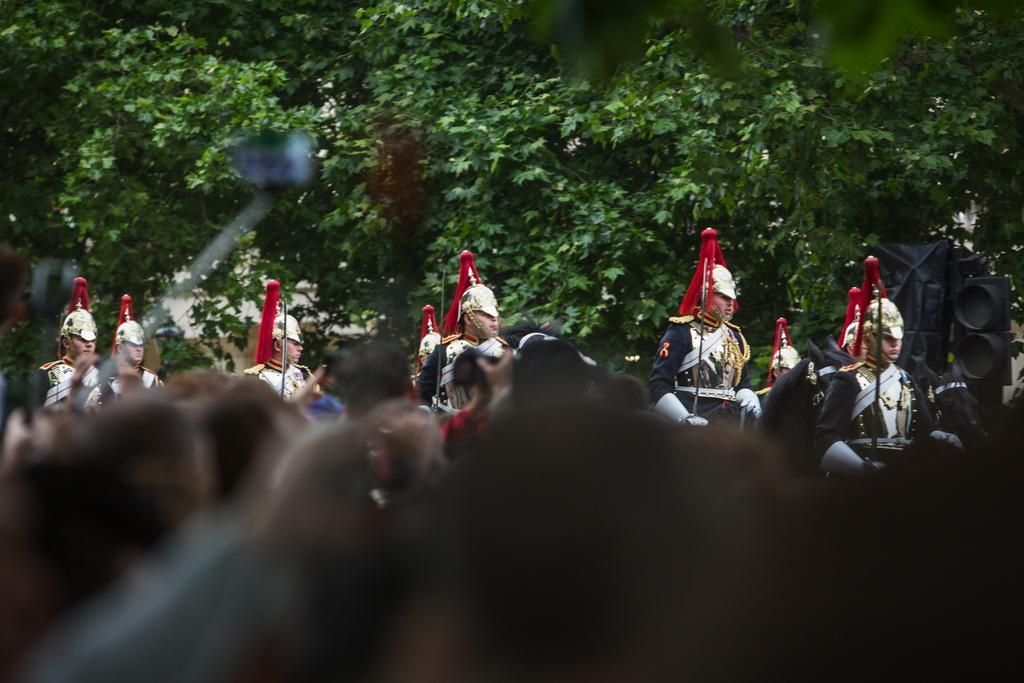How would you summarize this image in a sentence or two? In this image there are crowd in front of them there is a horse marching going on in the background there are trees. 